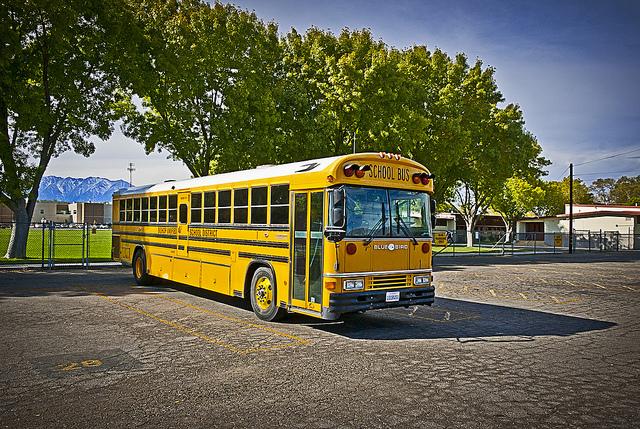What season is it?
Concise answer only. Spring. Why do you think there are no people here?
Concise answer only. No school. What color is the bus?
Keep it brief. Yellow. Is this likely at a school?
Short answer required. Yes. 